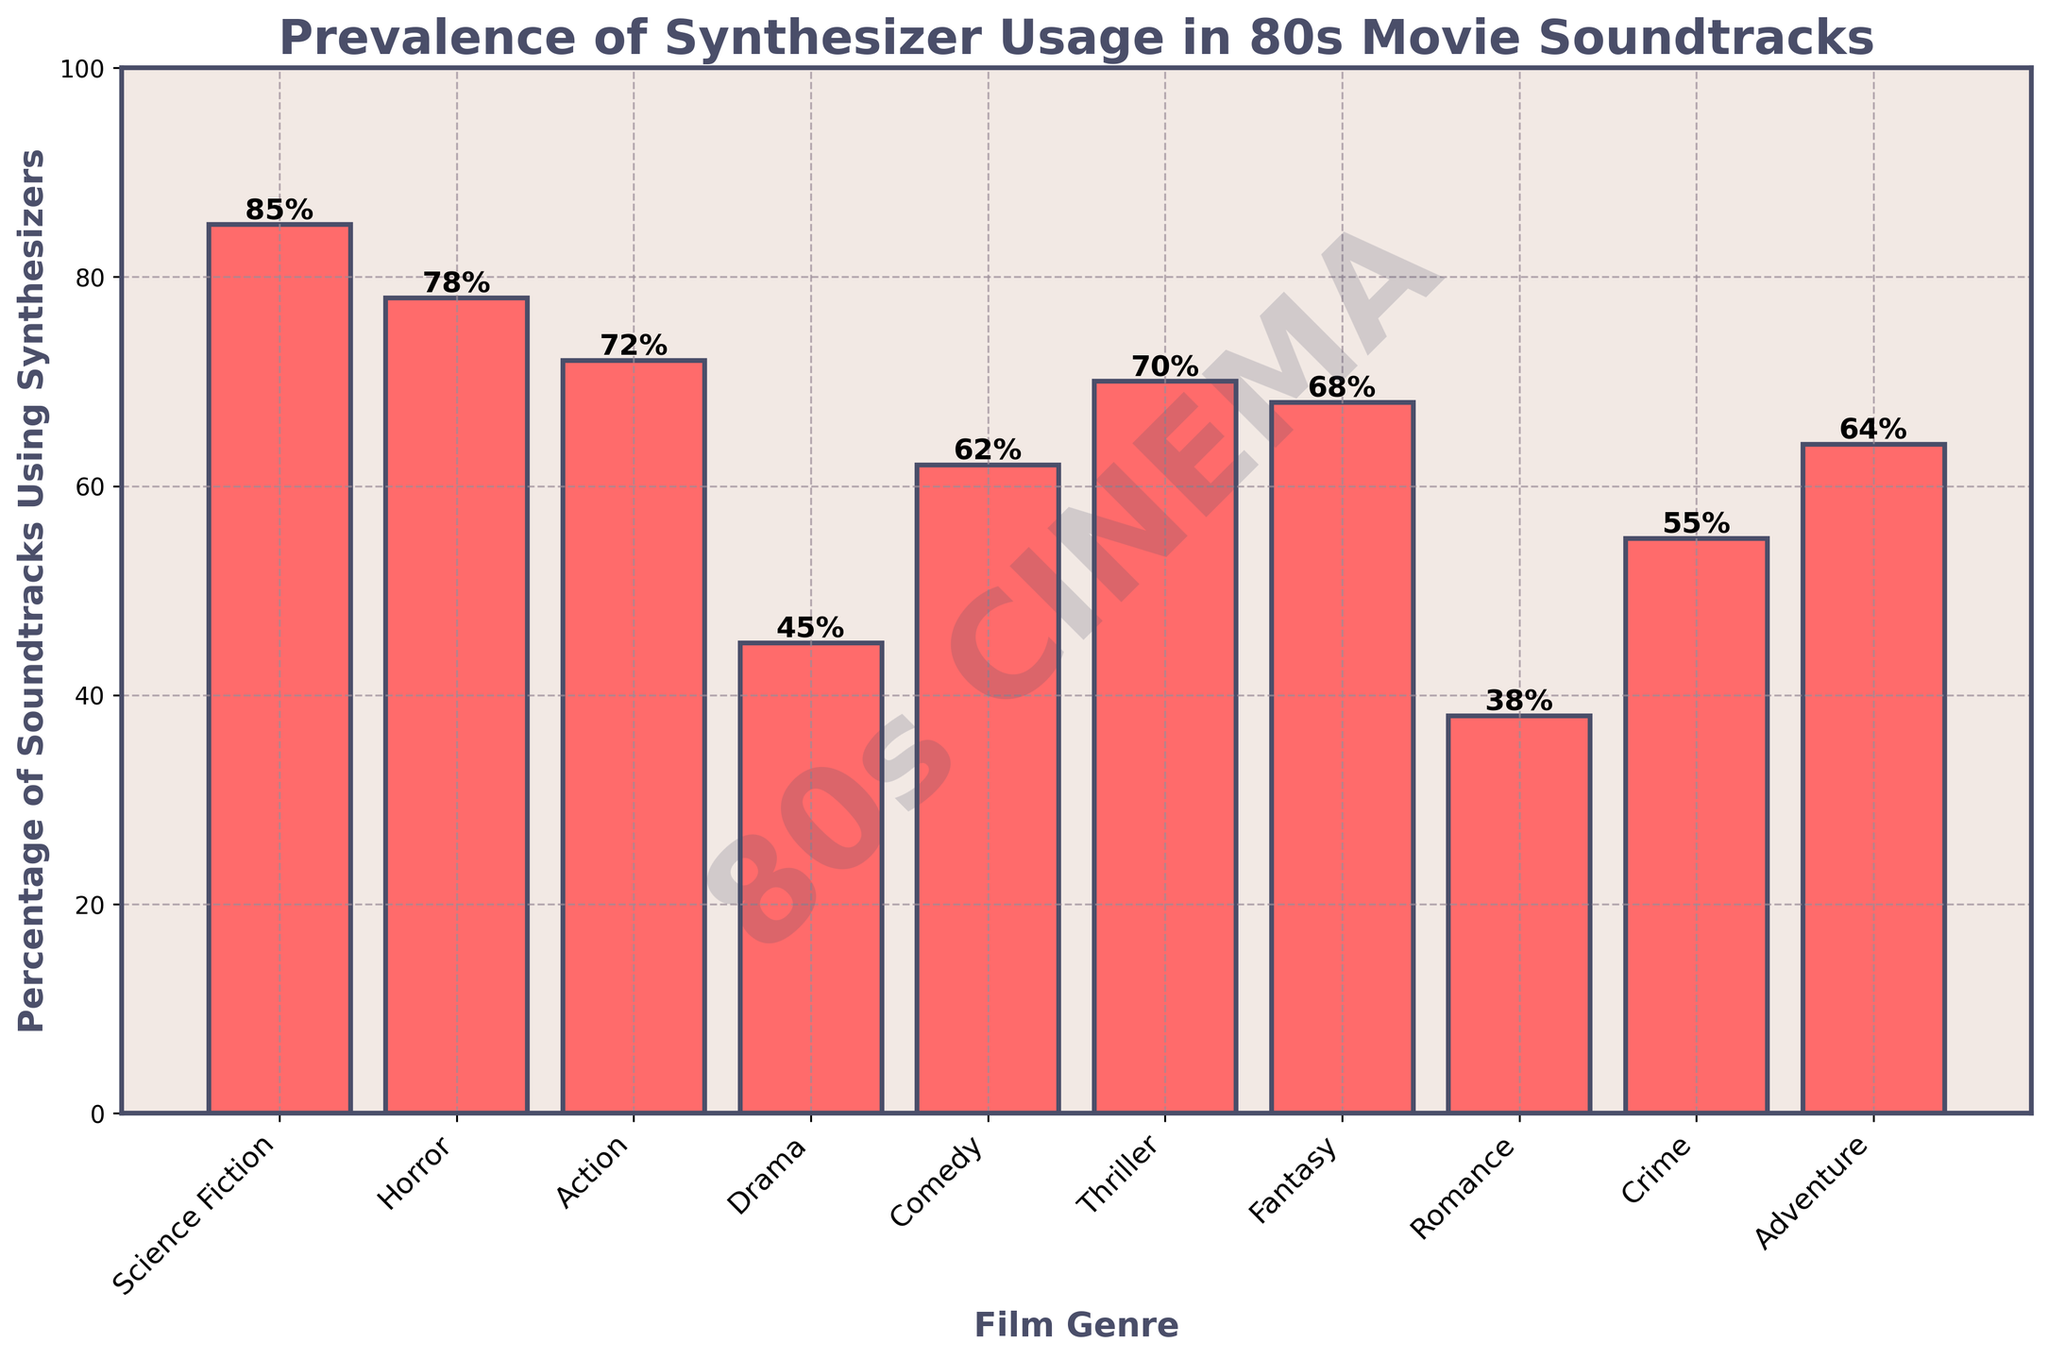Which film genre has the highest prevalence of synthesizer usage in 80s movie soundtracks? The highest bar represents the genre with the highest percentage, which is Science Fiction with 85%.
Answer: Science Fiction Which genre has a higher prevalence of synthesizer usage: Horror or Comedy? By comparing the heights of the bars, Horror (78%) is higher than Comedy (62%).
Answer: Horror What is the difference in synthesizer usage between Action and Romance genres? Calculate the difference by subtracting Romance (38%) from Action (72%): 72% - 38% = 34%.
Answer: 34% On average, what is the synthesizer usage percentage for Science Fiction, Thriller, and Crime genres? Add the percentages of Science Fiction (85%), Thriller (70%), and Crime (55%), then divide by 3: (85 + 70 + 55) / 3 = 70%.
Answer: 70% Compare the synthesizer usage in Drama to Adventure. Which one is higher, and by how much? Drama has 45% and Adventure has 64%. Adventure is higher. The difference is 64% - 45% = 19%.
Answer: Adventure by 19% Identify the genres with synthesizer usage below 50%. By checking the bars below the 50% line, Drama (45%) and Romance (38%) fall under this criteria.
Answer: Drama and Romance Which genre has the closest synthesizer usage percentage to 70%? By examining the bars close to 70%, Thriller at 70% is the closest.
Answer: Thriller What is the total synthesizer usage percentage for Horror, Comedy, and Fantasy genres combined? Sums up the percentages of Horror (78%), Comedy (62%), and Fantasy (68%): 78 + 62 + 68 = 208%.
Answer: 208% What is the percentage range shown in the bar chart? The minimum percentage shown is 38% (Romance) and the maximum is 85% (Science Fiction). The range is 85% - 38% = 47%.
Answer: 47% 